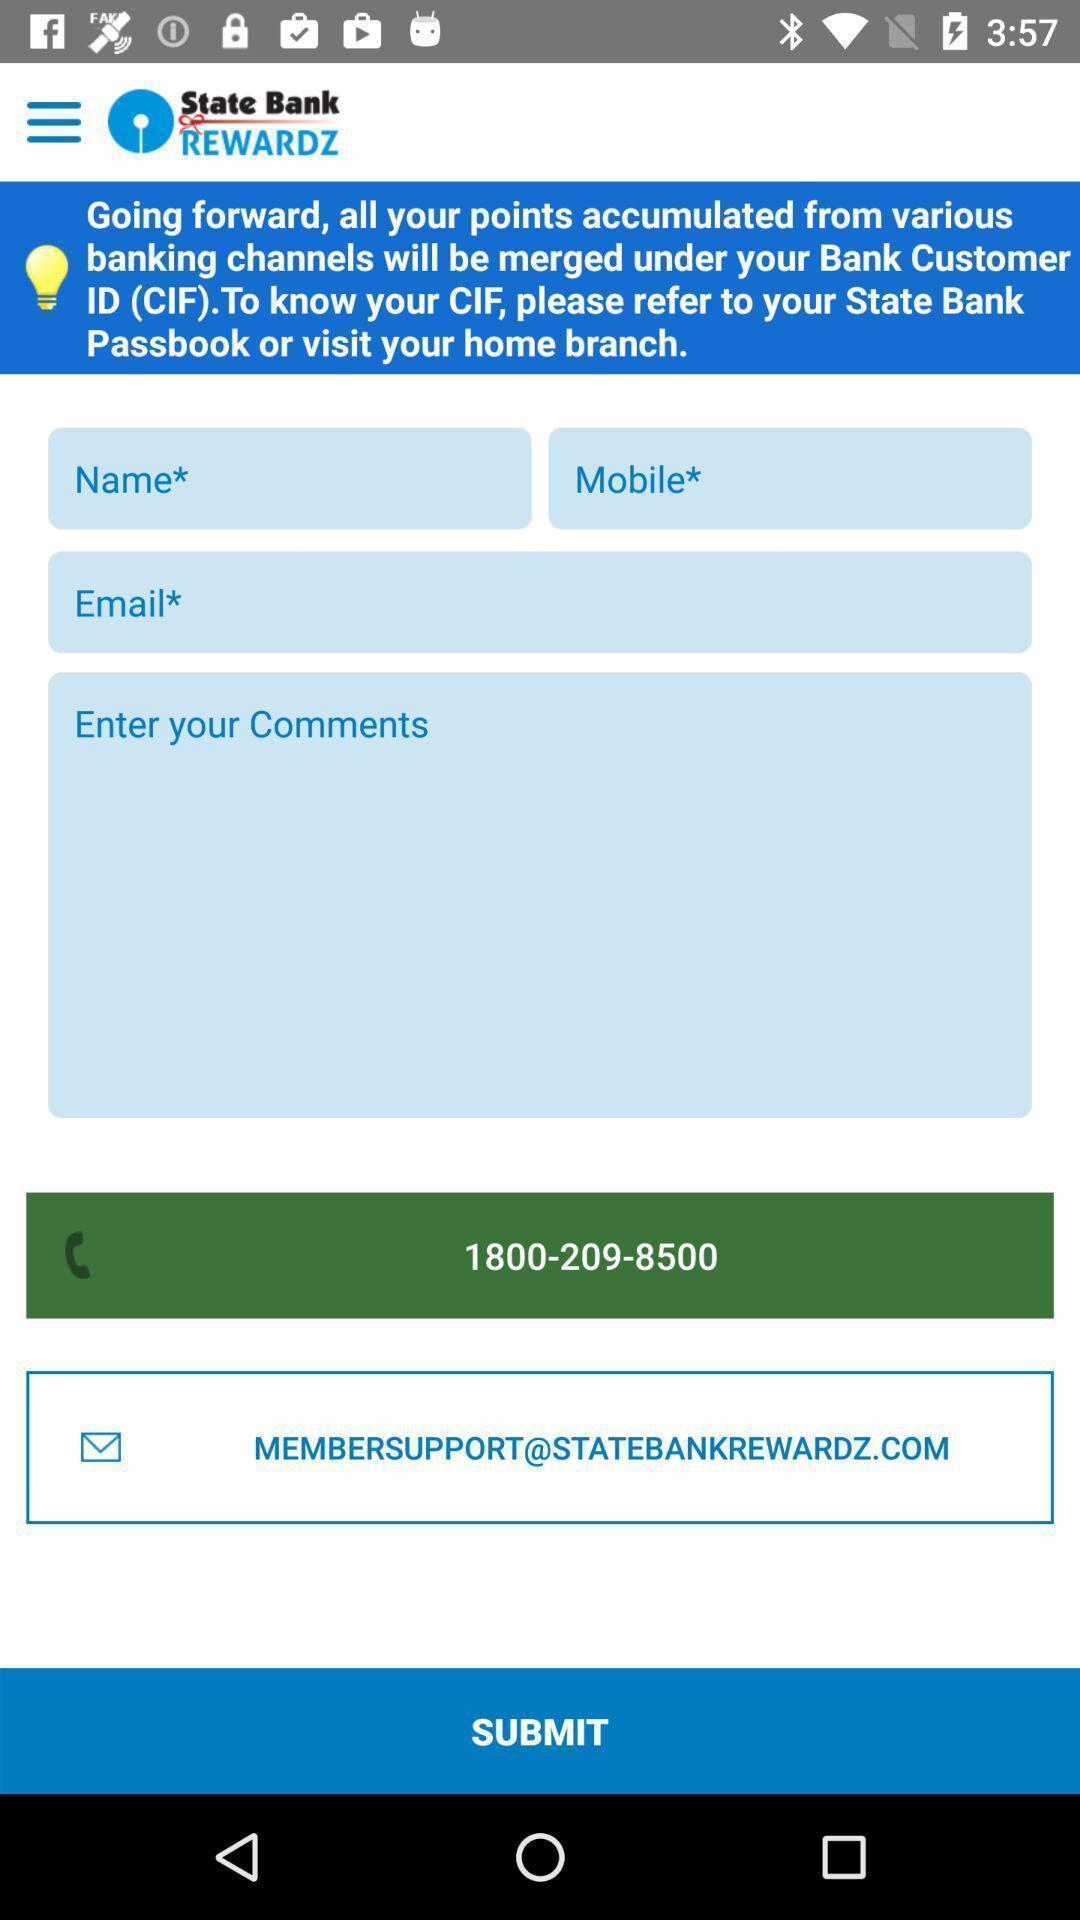Describe the key features of this screenshot. Screen page displaying various details to filled in financial application. 